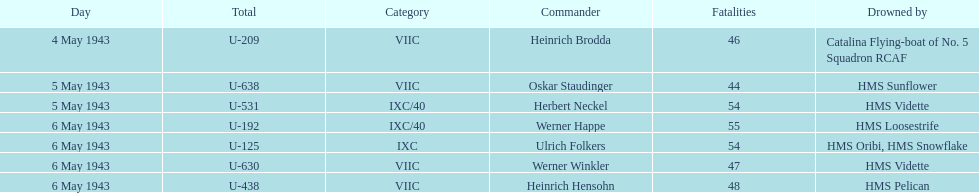Give me the full table as a dictionary. {'header': ['Day', 'Total', 'Category', 'Commander', 'Fatalities', 'Drowned by'], 'rows': [['4 May 1943', 'U-209', 'VIIC', 'Heinrich Brodda', '46', 'Catalina Flying-boat of No. 5 Squadron RCAF'], ['5 May 1943', 'U-638', 'VIIC', 'Oskar Staudinger', '44', 'HMS Sunflower'], ['5 May 1943', 'U-531', 'IXC/40', 'Herbert Neckel', '54', 'HMS Vidette'], ['6 May 1943', 'U-192', 'IXC/40', 'Werner Happe', '55', 'HMS Loosestrife'], ['6 May 1943', 'U-125', 'IXC', 'Ulrich Folkers', '54', 'HMS Oribi, HMS Snowflake'], ['6 May 1943', 'U-630', 'VIIC', 'Werner Winkler', '47', 'HMS Vidette'], ['6 May 1943', 'U-438', 'VIIC', 'Heinrich Hensohn', '48', 'HMS Pelican']]} How many captains are listed? 7. 